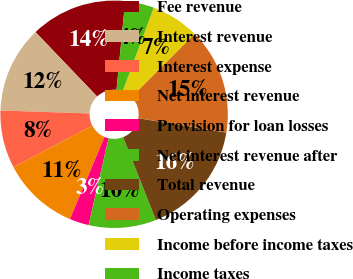<chart> <loc_0><loc_0><loc_500><loc_500><pie_chart><fcel>Fee revenue<fcel>Interest revenue<fcel>Interest expense<fcel>Net interest revenue<fcel>Provision for loan losses<fcel>Net interest revenue after<fcel>Total revenue<fcel>Operating expenses<fcel>Income before income taxes<fcel>Income taxes<nl><fcel>13.7%<fcel>12.33%<fcel>8.22%<fcel>10.96%<fcel>2.74%<fcel>9.59%<fcel>16.43%<fcel>15.06%<fcel>6.85%<fcel>4.11%<nl></chart> 